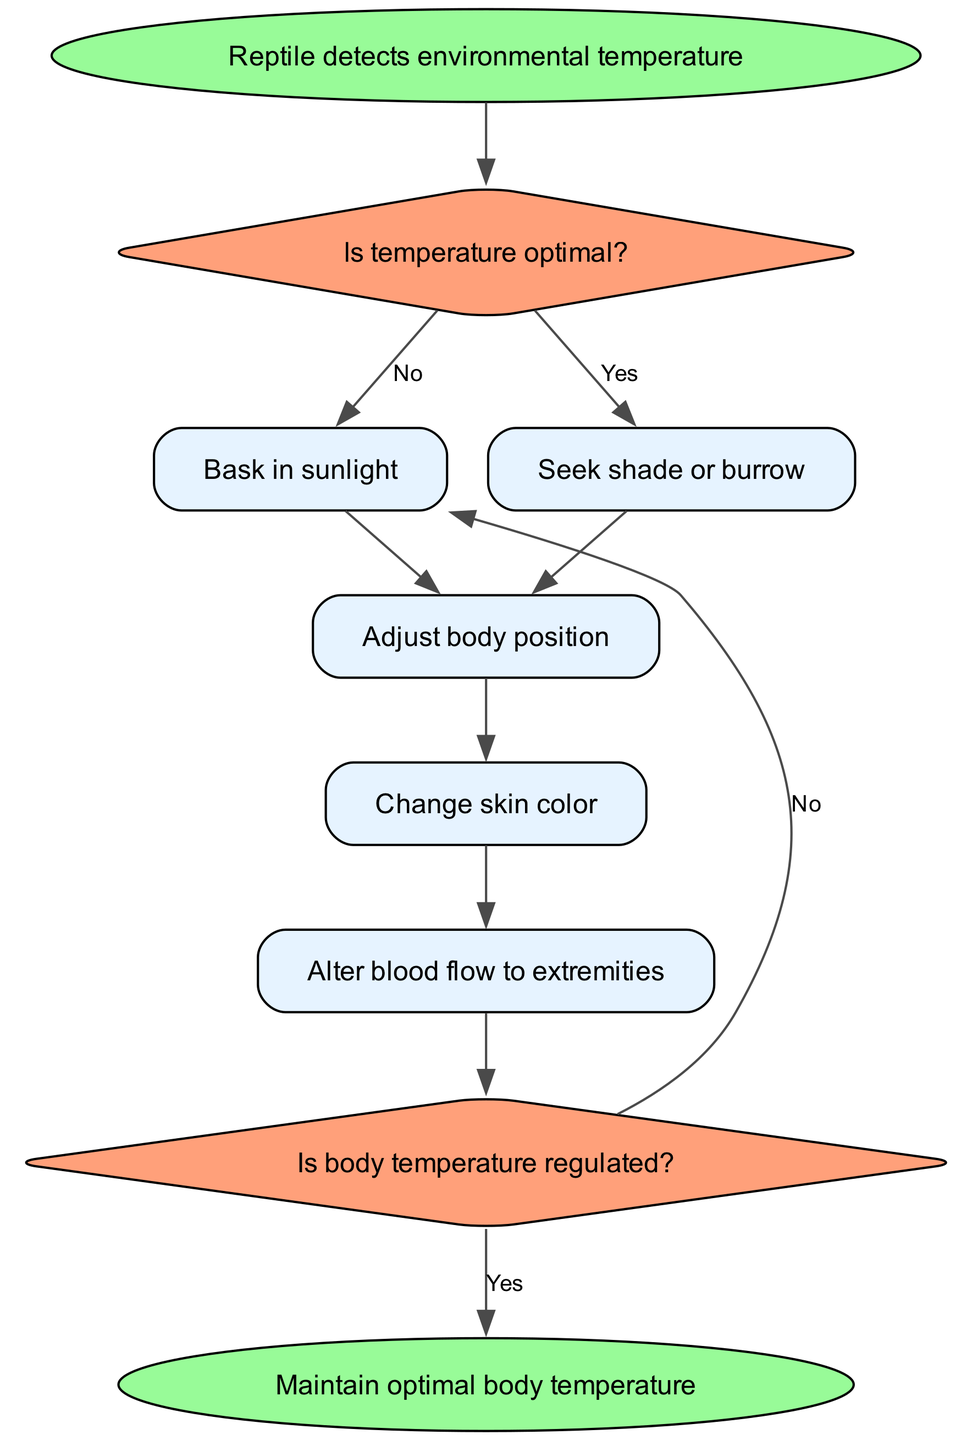What is the first step in the thermoregulation process? The first step is that the reptile detects environmental temperature. This is indicated as the starting node of the flowchart.
Answer: Reptile detects environmental temperature How many processes follow the first decision? After the first decision node, there are three processes that follow if the temperature is not optimal: bask in sunlight, seek shade or burrow, and adjust body position. Counting the processes leads to the answer.
Answer: Three What happens if the temperature is optimal? If the temperature is optimal, the flowchart indicates that the reptile does not bask in sunlight, but instead seeks shade or burrows. This is directly stated in the decision flow.
Answer: Seek shade or burrow What action follows adjusting body position? The next action that follows adjusting body position, according to the flowchart, is changing skin color. This shows the sequential process that follows the initial adjustment.
Answer: Change skin color What decision is made after altering blood flow? After altering blood flow to extremities, the next decision is about whether the body temperature is regulated. This is pointed out as the second decision node in the flowchart.
Answer: Is body temperature regulated? If the body temperature is not regulated, what is the next step? If the body temperature is not regulated, the flowchart indicates that the process will go back to basking in sunlight. This indicates that the reptile will need to repeat a part of the process to achieve regulation.
Answer: Bask in sunlight What shapes are used for decision nodes in the diagram? The decision nodes in the diagram are represented by diamond shapes, which is a common convention for showing decision points in flowcharts. This observation comes from analyzing the shapes depicted.
Answer: Diamond How many edges are connected to the end node? The end node has two edges connected to it: one from the second decision node indicating 'Yes' and another from the same decision node indicating 'No' that connects back to the basking process. Counting these gives the answer.
Answer: Two What is the final outcome of the thermoregulation process? The final outcome of the thermoregulation process, as illustrated at the end node, is maintaining an optimal body temperature. This is clearly stated as the end of the process in the flowchart.
Answer: Maintain optimal body temperature 